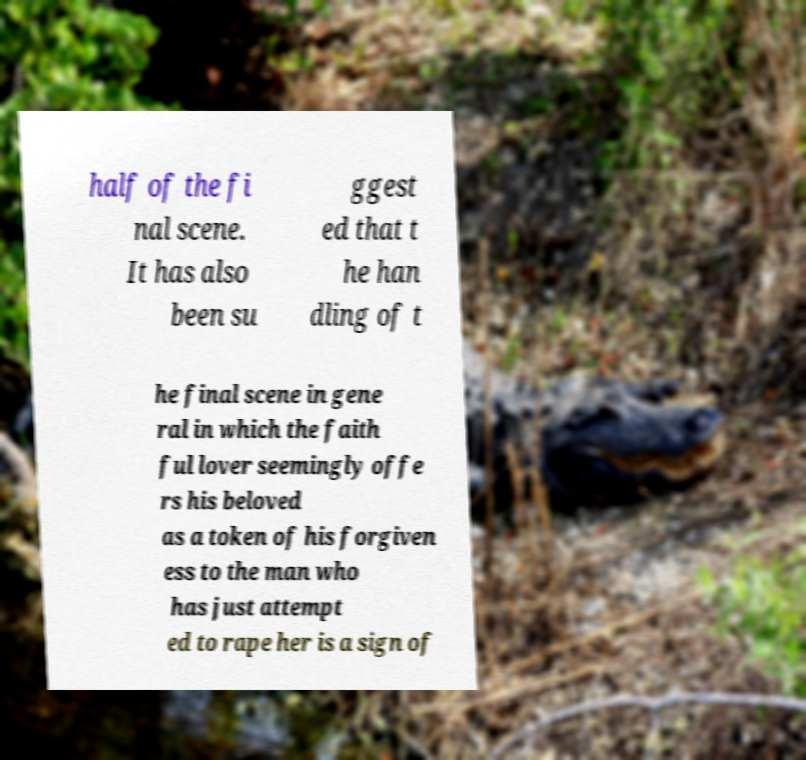Please identify and transcribe the text found in this image. half of the fi nal scene. It has also been su ggest ed that t he han dling of t he final scene in gene ral in which the faith ful lover seemingly offe rs his beloved as a token of his forgiven ess to the man who has just attempt ed to rape her is a sign of 